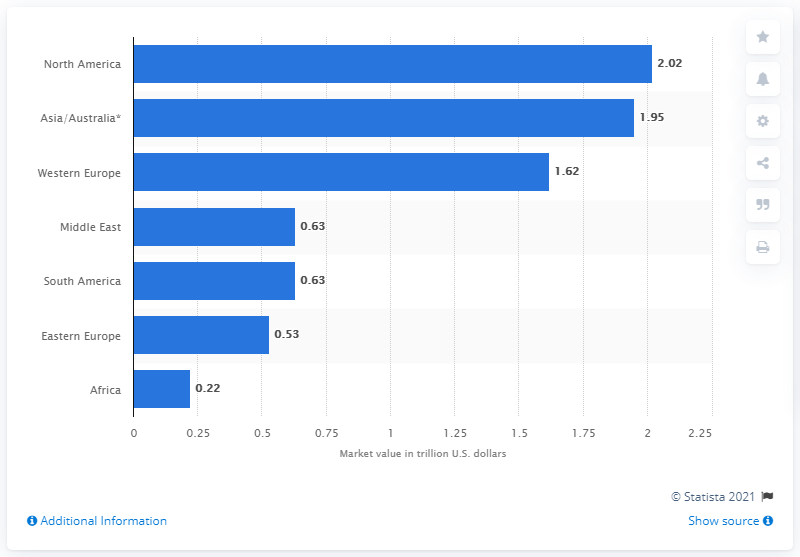Give some essential details in this illustration. The expected value for the Western European EPC (Energy Performance Contracting) market by the end of 2019 is 1.62 billion US dollars. 